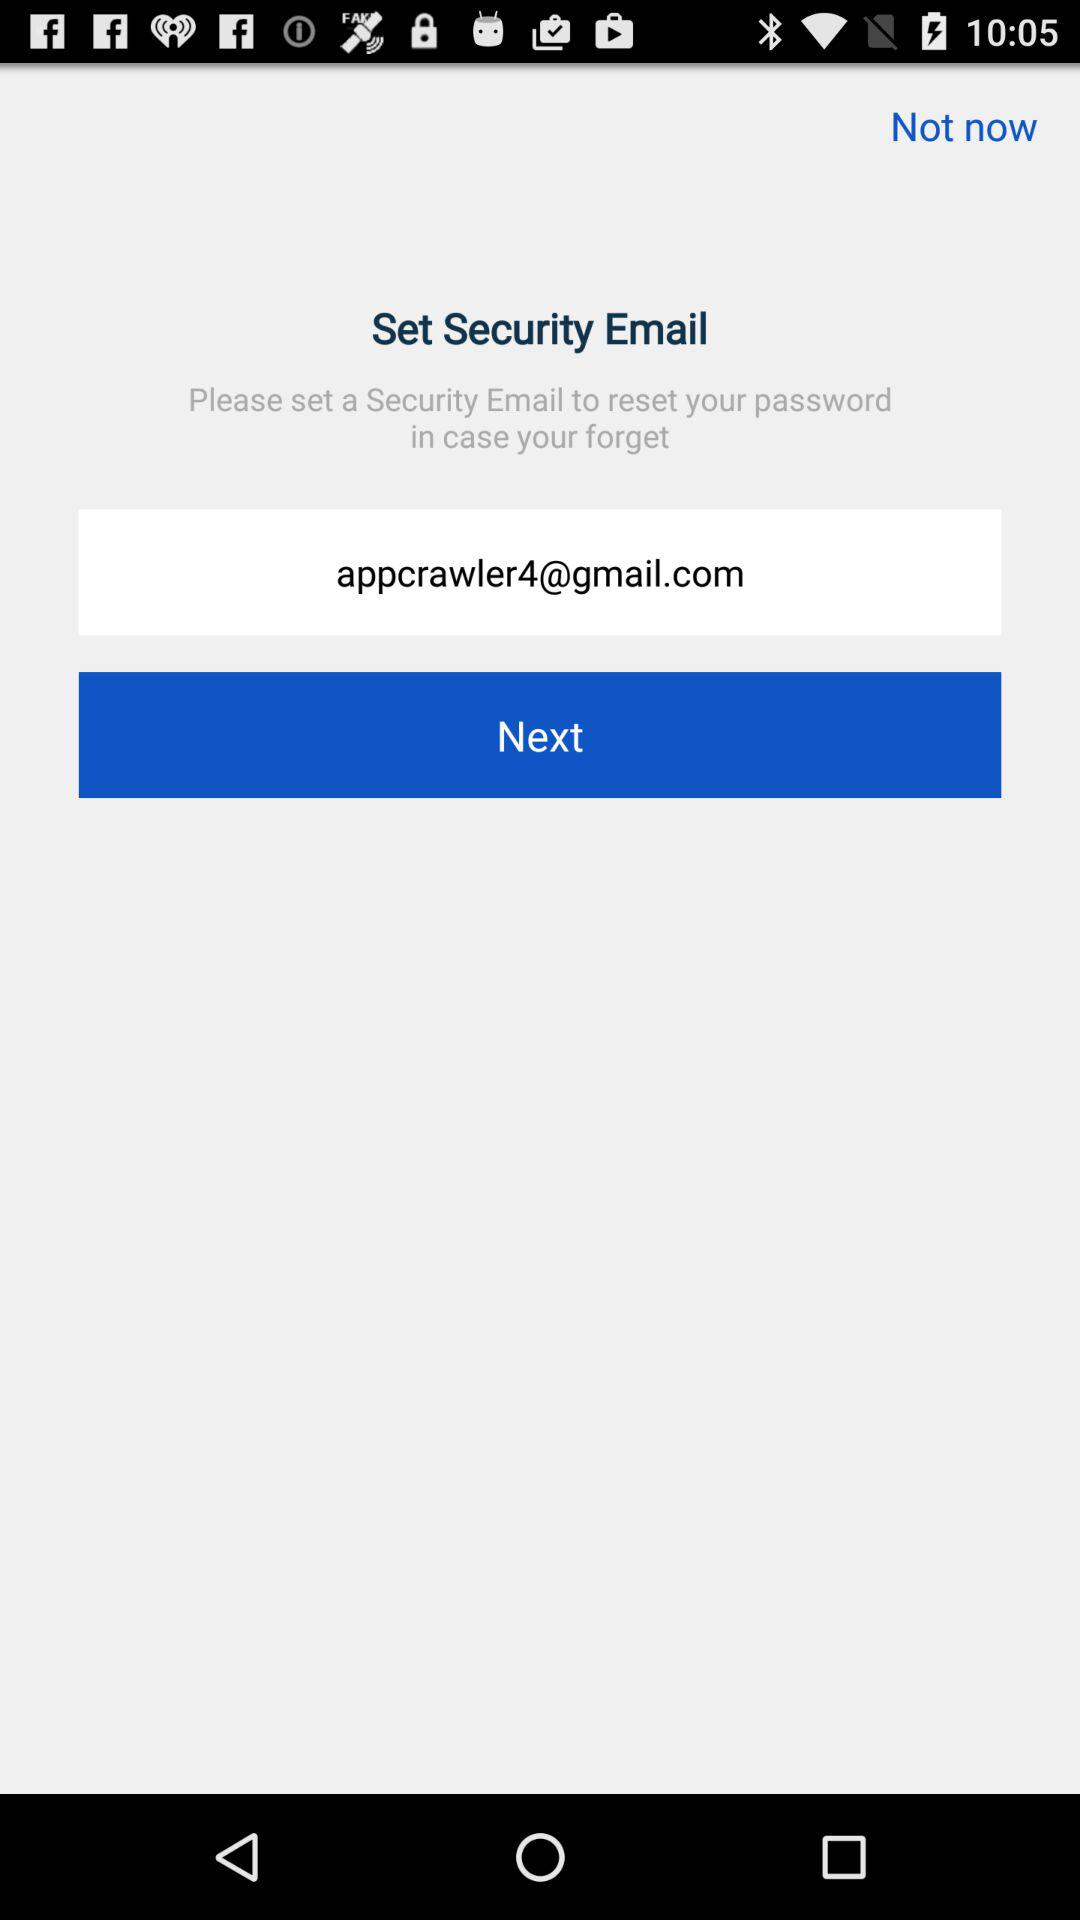What is the email address? The email address is appcrawler4@gmail.com. 